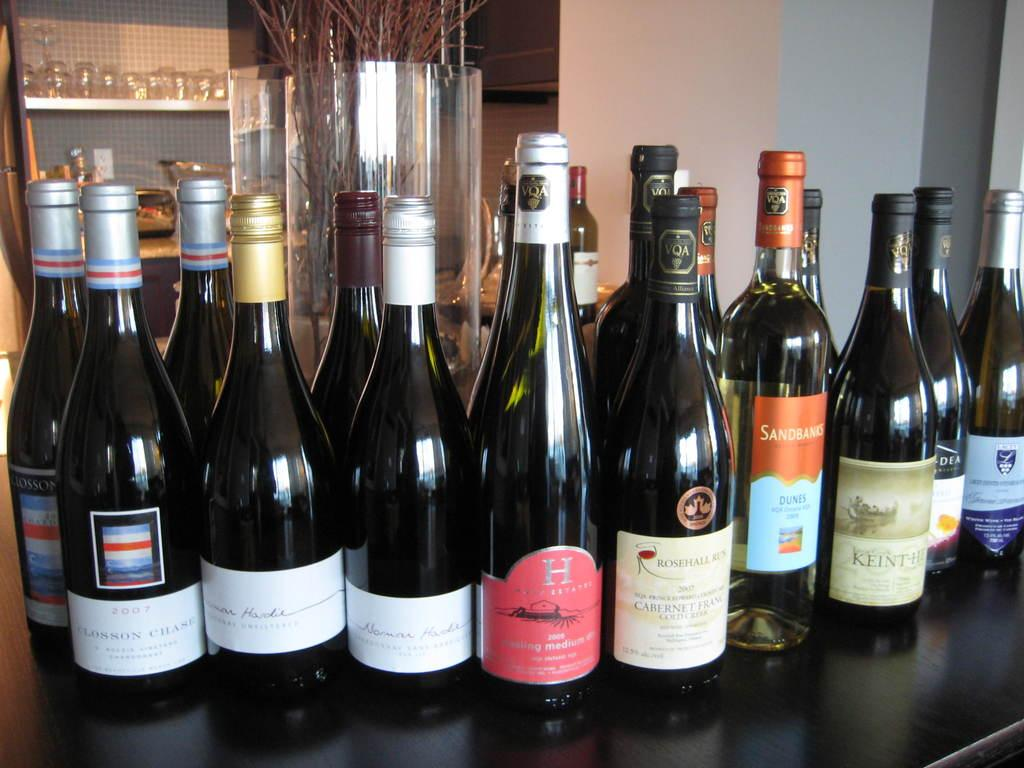<image>
Create a compact narrative representing the image presented. A bottle of wine with a red label with a big letter H on it stands with many other wine bottles. 